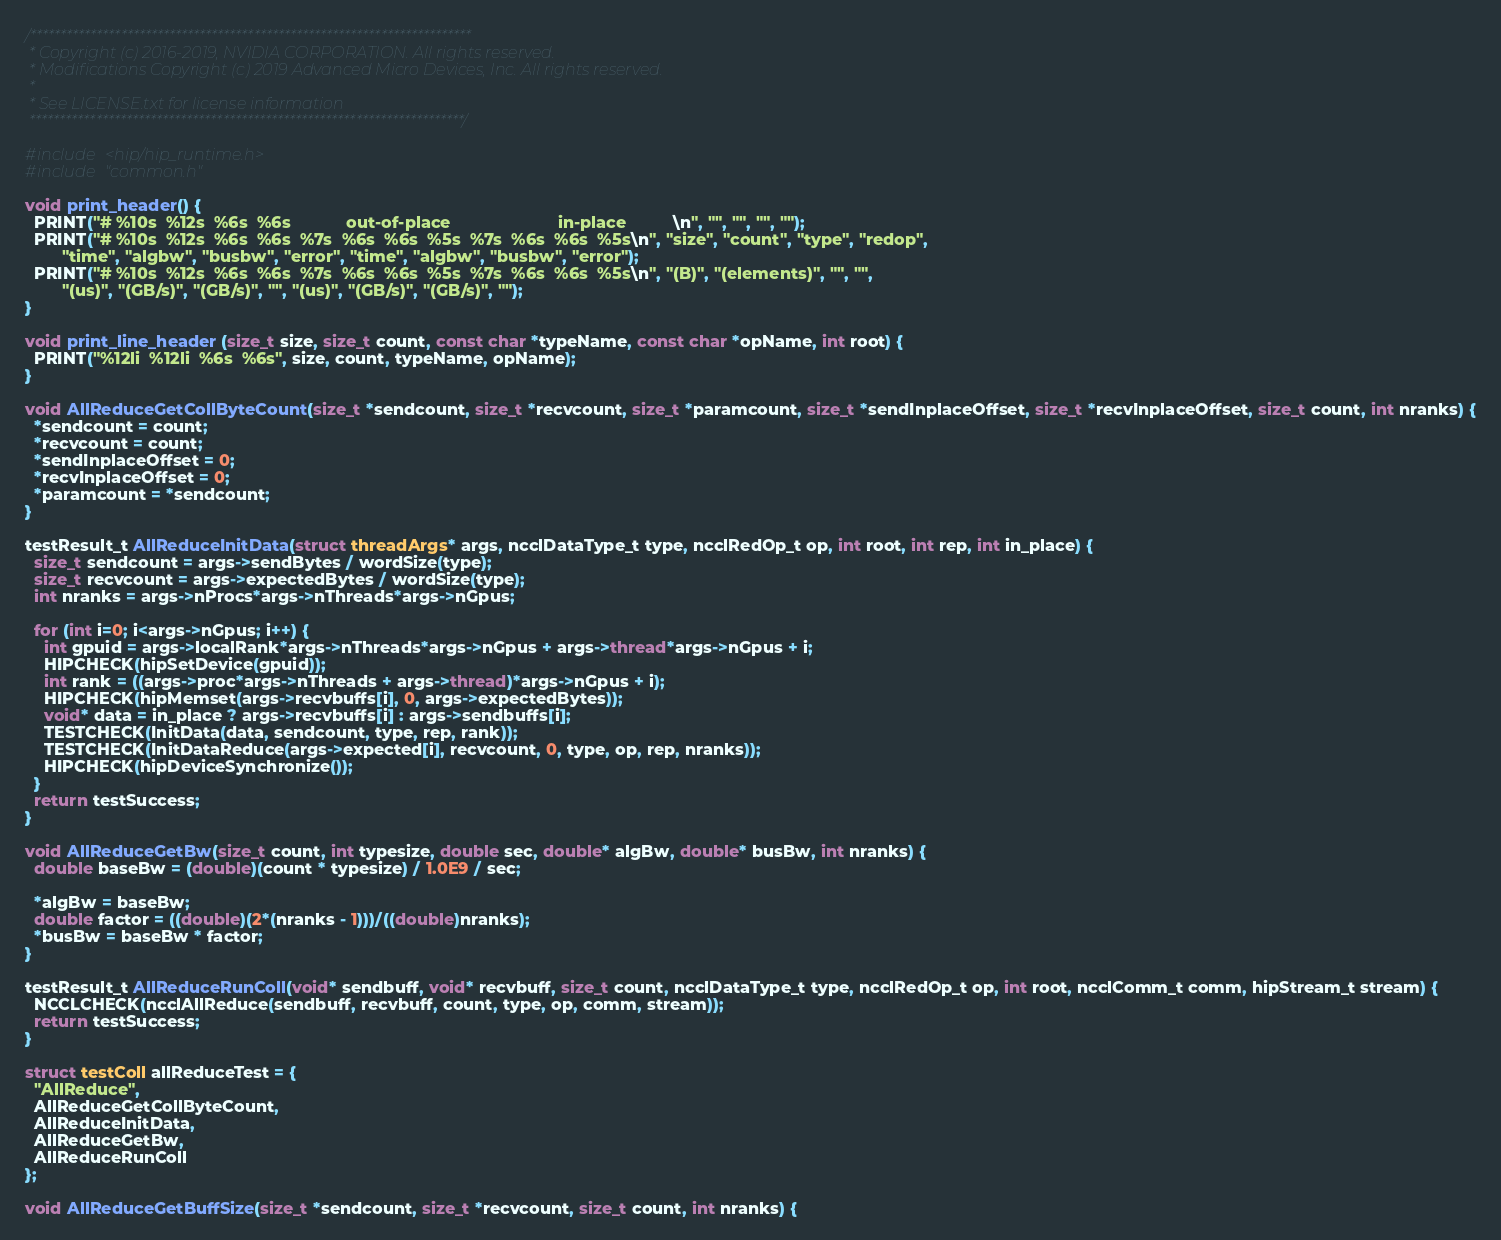<code> <loc_0><loc_0><loc_500><loc_500><_Cuda_>/*************************************************************************
 * Copyright (c) 2016-2019, NVIDIA CORPORATION. All rights reserved.
 * Modifications Copyright (c) 2019 Advanced Micro Devices, Inc. All rights reserved.
 *
 * See LICENSE.txt for license information
 ************************************************************************/

#include <hip/hip_runtime.h>
#include "common.h"

void print_header() {
  PRINT("# %10s  %12s  %6s  %6s            out-of-place                       in-place          \n", "", "", "", "");
  PRINT("# %10s  %12s  %6s  %6s  %7s  %6s  %6s  %5s  %7s  %6s  %6s  %5s\n", "size", "count", "type", "redop",
        "time", "algbw", "busbw", "error", "time", "algbw", "busbw", "error");
  PRINT("# %10s  %12s  %6s  %6s  %7s  %6s  %6s  %5s  %7s  %6s  %6s  %5s\n", "(B)", "(elements)", "", "",
        "(us)", "(GB/s)", "(GB/s)", "", "(us)", "(GB/s)", "(GB/s)", "");
}

void print_line_header (size_t size, size_t count, const char *typeName, const char *opName, int root) {
  PRINT("%12li  %12li  %6s  %6s", size, count, typeName, opName);
}

void AllReduceGetCollByteCount(size_t *sendcount, size_t *recvcount, size_t *paramcount, size_t *sendInplaceOffset, size_t *recvInplaceOffset, size_t count, int nranks) {
  *sendcount = count;
  *recvcount = count;
  *sendInplaceOffset = 0;
  *recvInplaceOffset = 0;
  *paramcount = *sendcount;
}

testResult_t AllReduceInitData(struct threadArgs* args, ncclDataType_t type, ncclRedOp_t op, int root, int rep, int in_place) {
  size_t sendcount = args->sendBytes / wordSize(type);
  size_t recvcount = args->expectedBytes / wordSize(type);
  int nranks = args->nProcs*args->nThreads*args->nGpus;

  for (int i=0; i<args->nGpus; i++) {
    int gpuid = args->localRank*args->nThreads*args->nGpus + args->thread*args->nGpus + i;
    HIPCHECK(hipSetDevice(gpuid));
    int rank = ((args->proc*args->nThreads + args->thread)*args->nGpus + i);
    HIPCHECK(hipMemset(args->recvbuffs[i], 0, args->expectedBytes));
    void* data = in_place ? args->recvbuffs[i] : args->sendbuffs[i];
    TESTCHECK(InitData(data, sendcount, type, rep, rank));
    TESTCHECK(InitDataReduce(args->expected[i], recvcount, 0, type, op, rep, nranks));
    HIPCHECK(hipDeviceSynchronize());
  }
  return testSuccess;
}

void AllReduceGetBw(size_t count, int typesize, double sec, double* algBw, double* busBw, int nranks) {
  double baseBw = (double)(count * typesize) / 1.0E9 / sec;

  *algBw = baseBw;
  double factor = ((double)(2*(nranks - 1)))/((double)nranks);
  *busBw = baseBw * factor;
}

testResult_t AllReduceRunColl(void* sendbuff, void* recvbuff, size_t count, ncclDataType_t type, ncclRedOp_t op, int root, ncclComm_t comm, hipStream_t stream) {
  NCCLCHECK(ncclAllReduce(sendbuff, recvbuff, count, type, op, comm, stream));
  return testSuccess;
}

struct testColl allReduceTest = {
  "AllReduce",
  AllReduceGetCollByteCount,
  AllReduceInitData,
  AllReduceGetBw,
  AllReduceRunColl
};

void AllReduceGetBuffSize(size_t *sendcount, size_t *recvcount, size_t count, int nranks) {</code> 